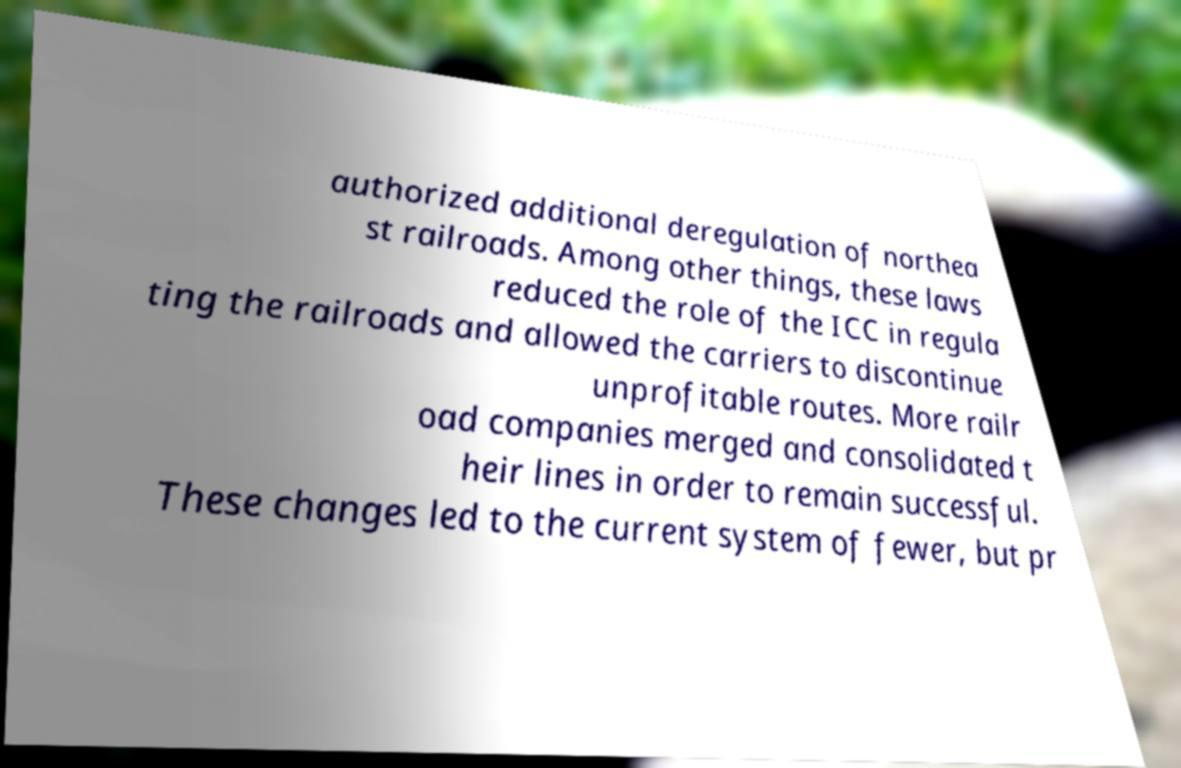Please identify and transcribe the text found in this image. authorized additional deregulation of northea st railroads. Among other things, these laws reduced the role of the ICC in regula ting the railroads and allowed the carriers to discontinue unprofitable routes. More railr oad companies merged and consolidated t heir lines in order to remain successful. These changes led to the current system of fewer, but pr 